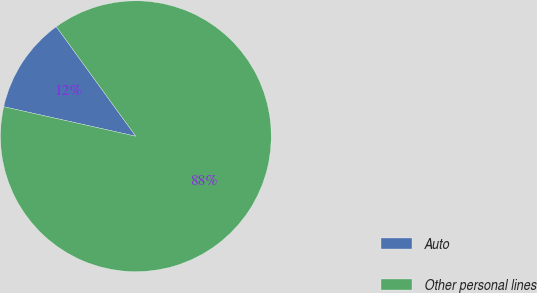Convert chart to OTSL. <chart><loc_0><loc_0><loc_500><loc_500><pie_chart><fcel>Auto<fcel>Other personal lines<nl><fcel>11.51%<fcel>88.49%<nl></chart> 